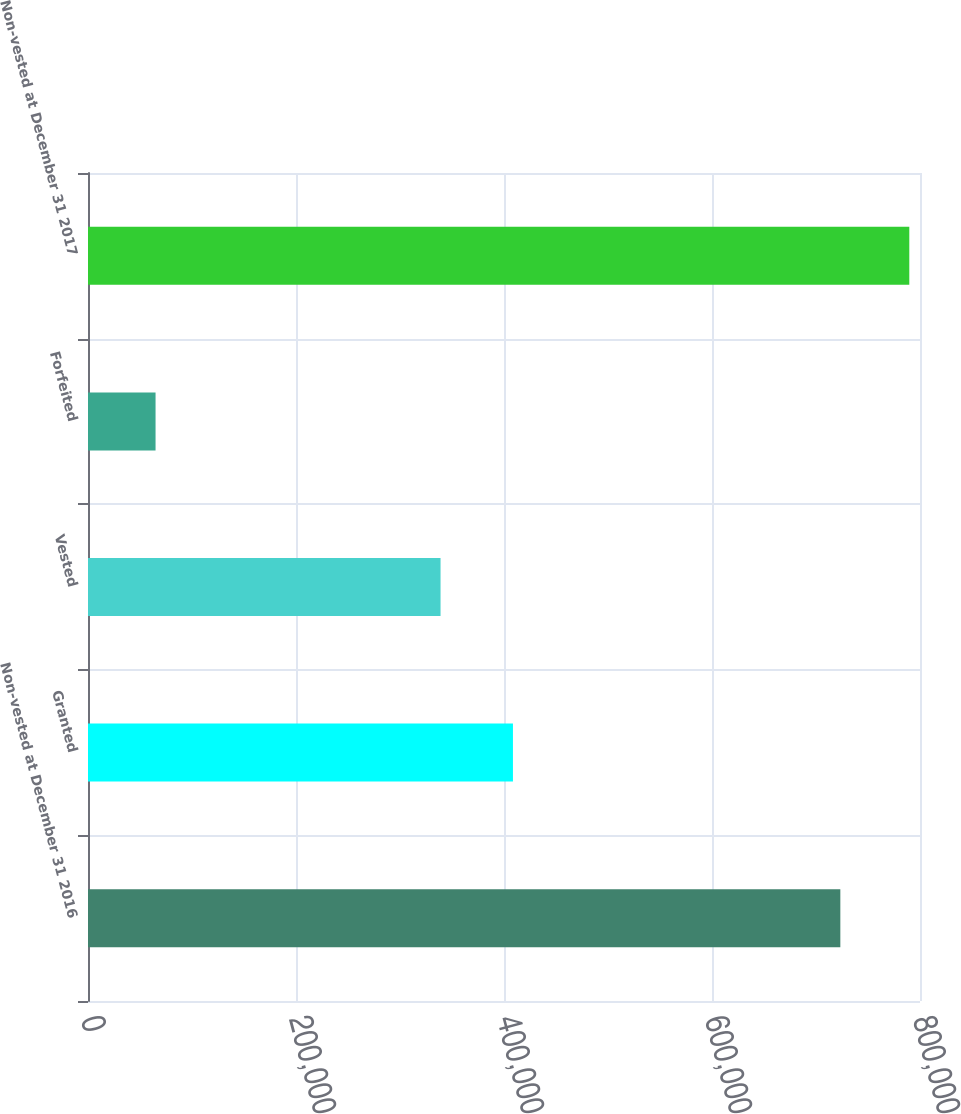Convert chart. <chart><loc_0><loc_0><loc_500><loc_500><bar_chart><fcel>Non-vested at December 31 2016<fcel>Granted<fcel>Vested<fcel>Forfeited<fcel>Non-vested at December 31 2017<nl><fcel>723398<fcel>408608<fcel>338988<fcel>64953<fcel>789709<nl></chart> 